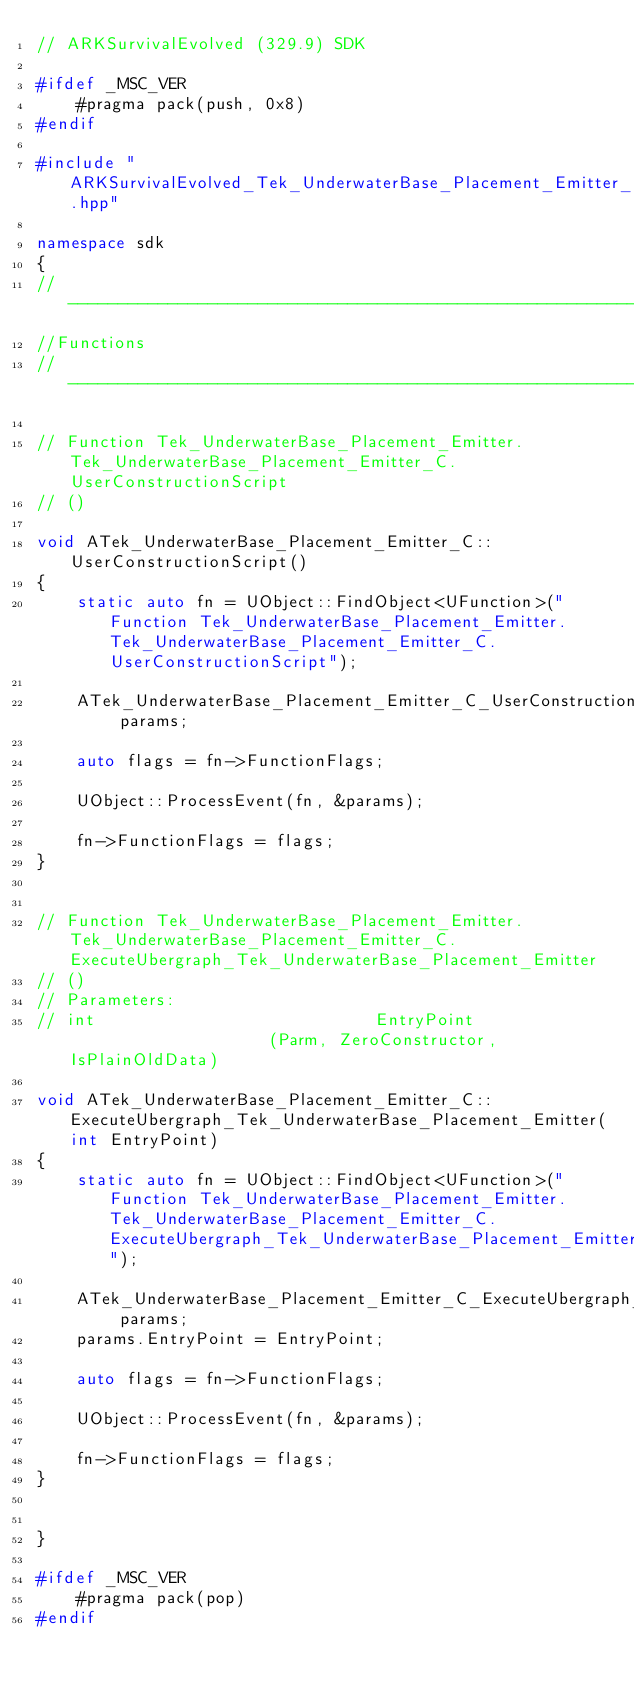Convert code to text. <code><loc_0><loc_0><loc_500><loc_500><_C++_>// ARKSurvivalEvolved (329.9) SDK

#ifdef _MSC_VER
	#pragma pack(push, 0x8)
#endif

#include "ARKSurvivalEvolved_Tek_UnderwaterBase_Placement_Emitter_parameters.hpp"

namespace sdk
{
//---------------------------------------------------------------------------
//Functions
//---------------------------------------------------------------------------

// Function Tek_UnderwaterBase_Placement_Emitter.Tek_UnderwaterBase_Placement_Emitter_C.UserConstructionScript
// ()

void ATek_UnderwaterBase_Placement_Emitter_C::UserConstructionScript()
{
	static auto fn = UObject::FindObject<UFunction>("Function Tek_UnderwaterBase_Placement_Emitter.Tek_UnderwaterBase_Placement_Emitter_C.UserConstructionScript");

	ATek_UnderwaterBase_Placement_Emitter_C_UserConstructionScript_Params params;

	auto flags = fn->FunctionFlags;

	UObject::ProcessEvent(fn, &params);

	fn->FunctionFlags = flags;
}


// Function Tek_UnderwaterBase_Placement_Emitter.Tek_UnderwaterBase_Placement_Emitter_C.ExecuteUbergraph_Tek_UnderwaterBase_Placement_Emitter
// ()
// Parameters:
// int                            EntryPoint                     (Parm, ZeroConstructor, IsPlainOldData)

void ATek_UnderwaterBase_Placement_Emitter_C::ExecuteUbergraph_Tek_UnderwaterBase_Placement_Emitter(int EntryPoint)
{
	static auto fn = UObject::FindObject<UFunction>("Function Tek_UnderwaterBase_Placement_Emitter.Tek_UnderwaterBase_Placement_Emitter_C.ExecuteUbergraph_Tek_UnderwaterBase_Placement_Emitter");

	ATek_UnderwaterBase_Placement_Emitter_C_ExecuteUbergraph_Tek_UnderwaterBase_Placement_Emitter_Params params;
	params.EntryPoint = EntryPoint;

	auto flags = fn->FunctionFlags;

	UObject::ProcessEvent(fn, &params);

	fn->FunctionFlags = flags;
}


}

#ifdef _MSC_VER
	#pragma pack(pop)
#endif
</code> 